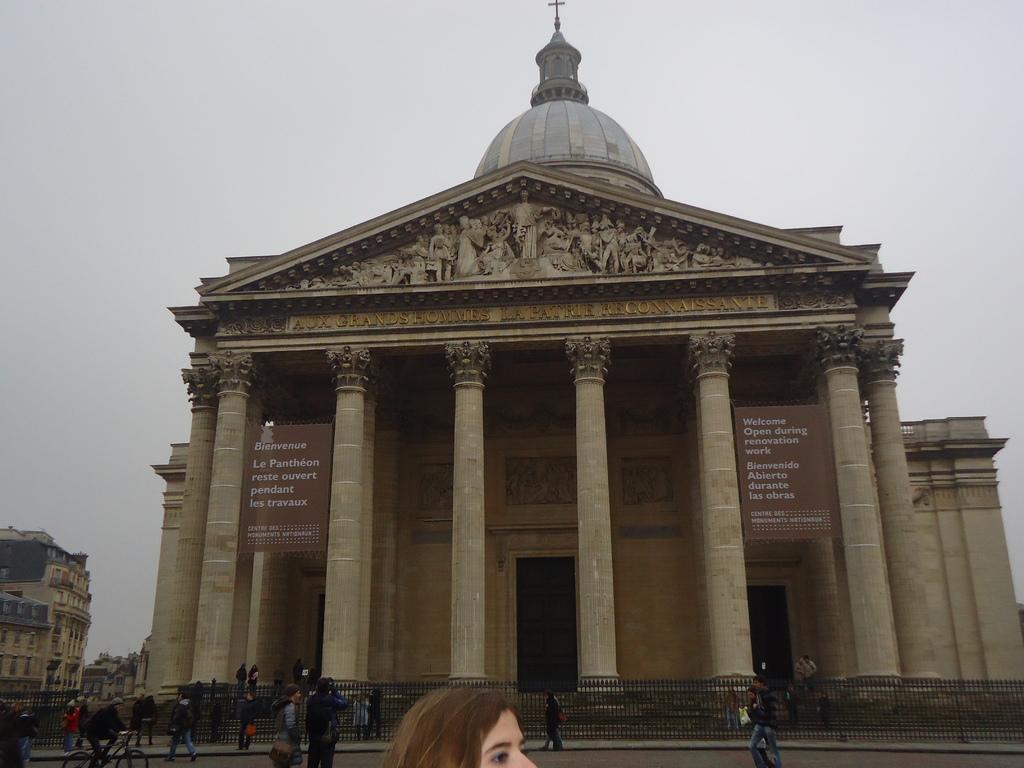In one or two sentences, can you explain what this image depicts? There is a building with pillars. On the building there are posters and sculptures. Also there are doors. In front of the building there are railings. And there are many people. One person is riding a cycle. On the left side there is another building. In the background there is sky. 